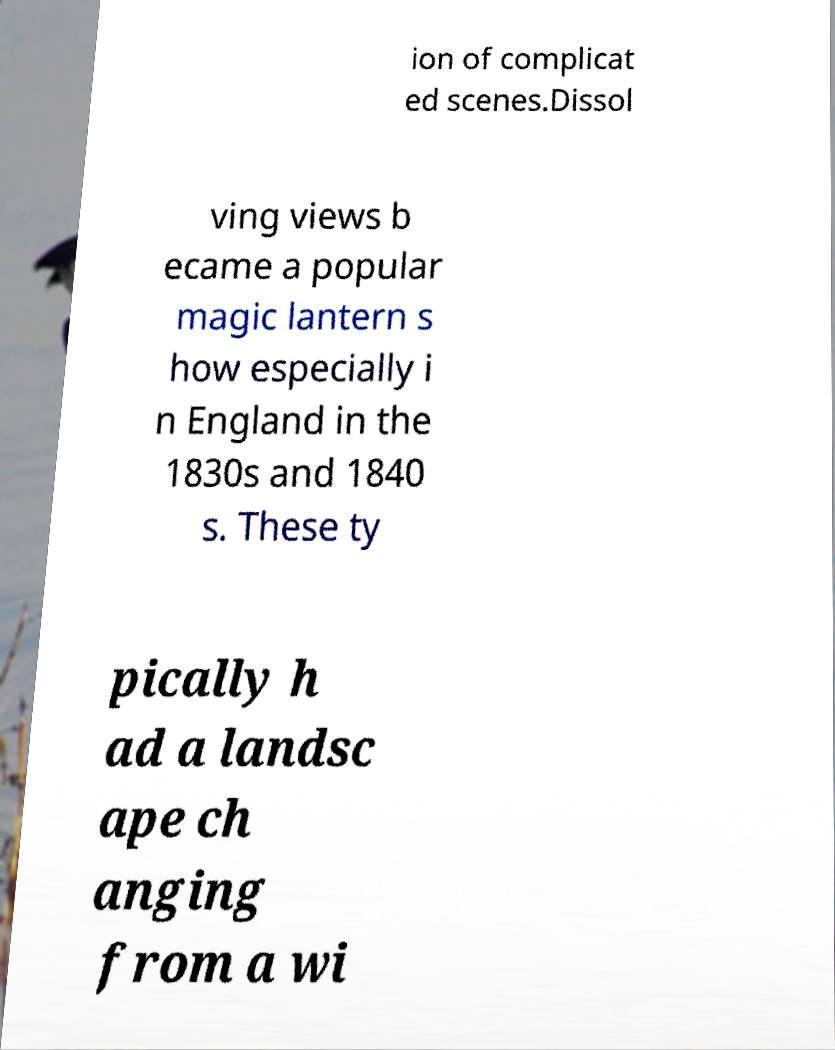What messages or text are displayed in this image? I need them in a readable, typed format. ion of complicat ed scenes.Dissol ving views b ecame a popular magic lantern s how especially i n England in the 1830s and 1840 s. These ty pically h ad a landsc ape ch anging from a wi 